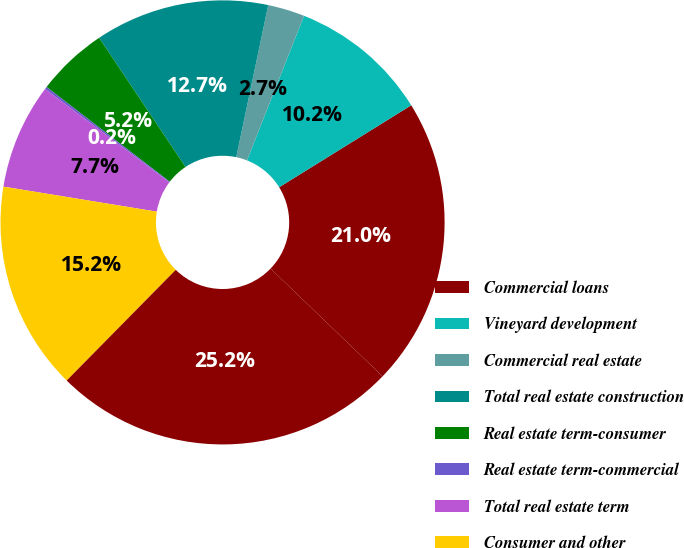Convert chart. <chart><loc_0><loc_0><loc_500><loc_500><pie_chart><fcel>Commercial loans<fcel>Vineyard development<fcel>Commercial real estate<fcel>Total real estate construction<fcel>Real estate term-consumer<fcel>Real estate term-commercial<fcel>Total real estate term<fcel>Consumer and other<fcel>Total loans net of unearned<nl><fcel>21.03%<fcel>10.18%<fcel>2.68%<fcel>12.68%<fcel>5.18%<fcel>0.18%<fcel>7.68%<fcel>15.19%<fcel>25.19%<nl></chart> 